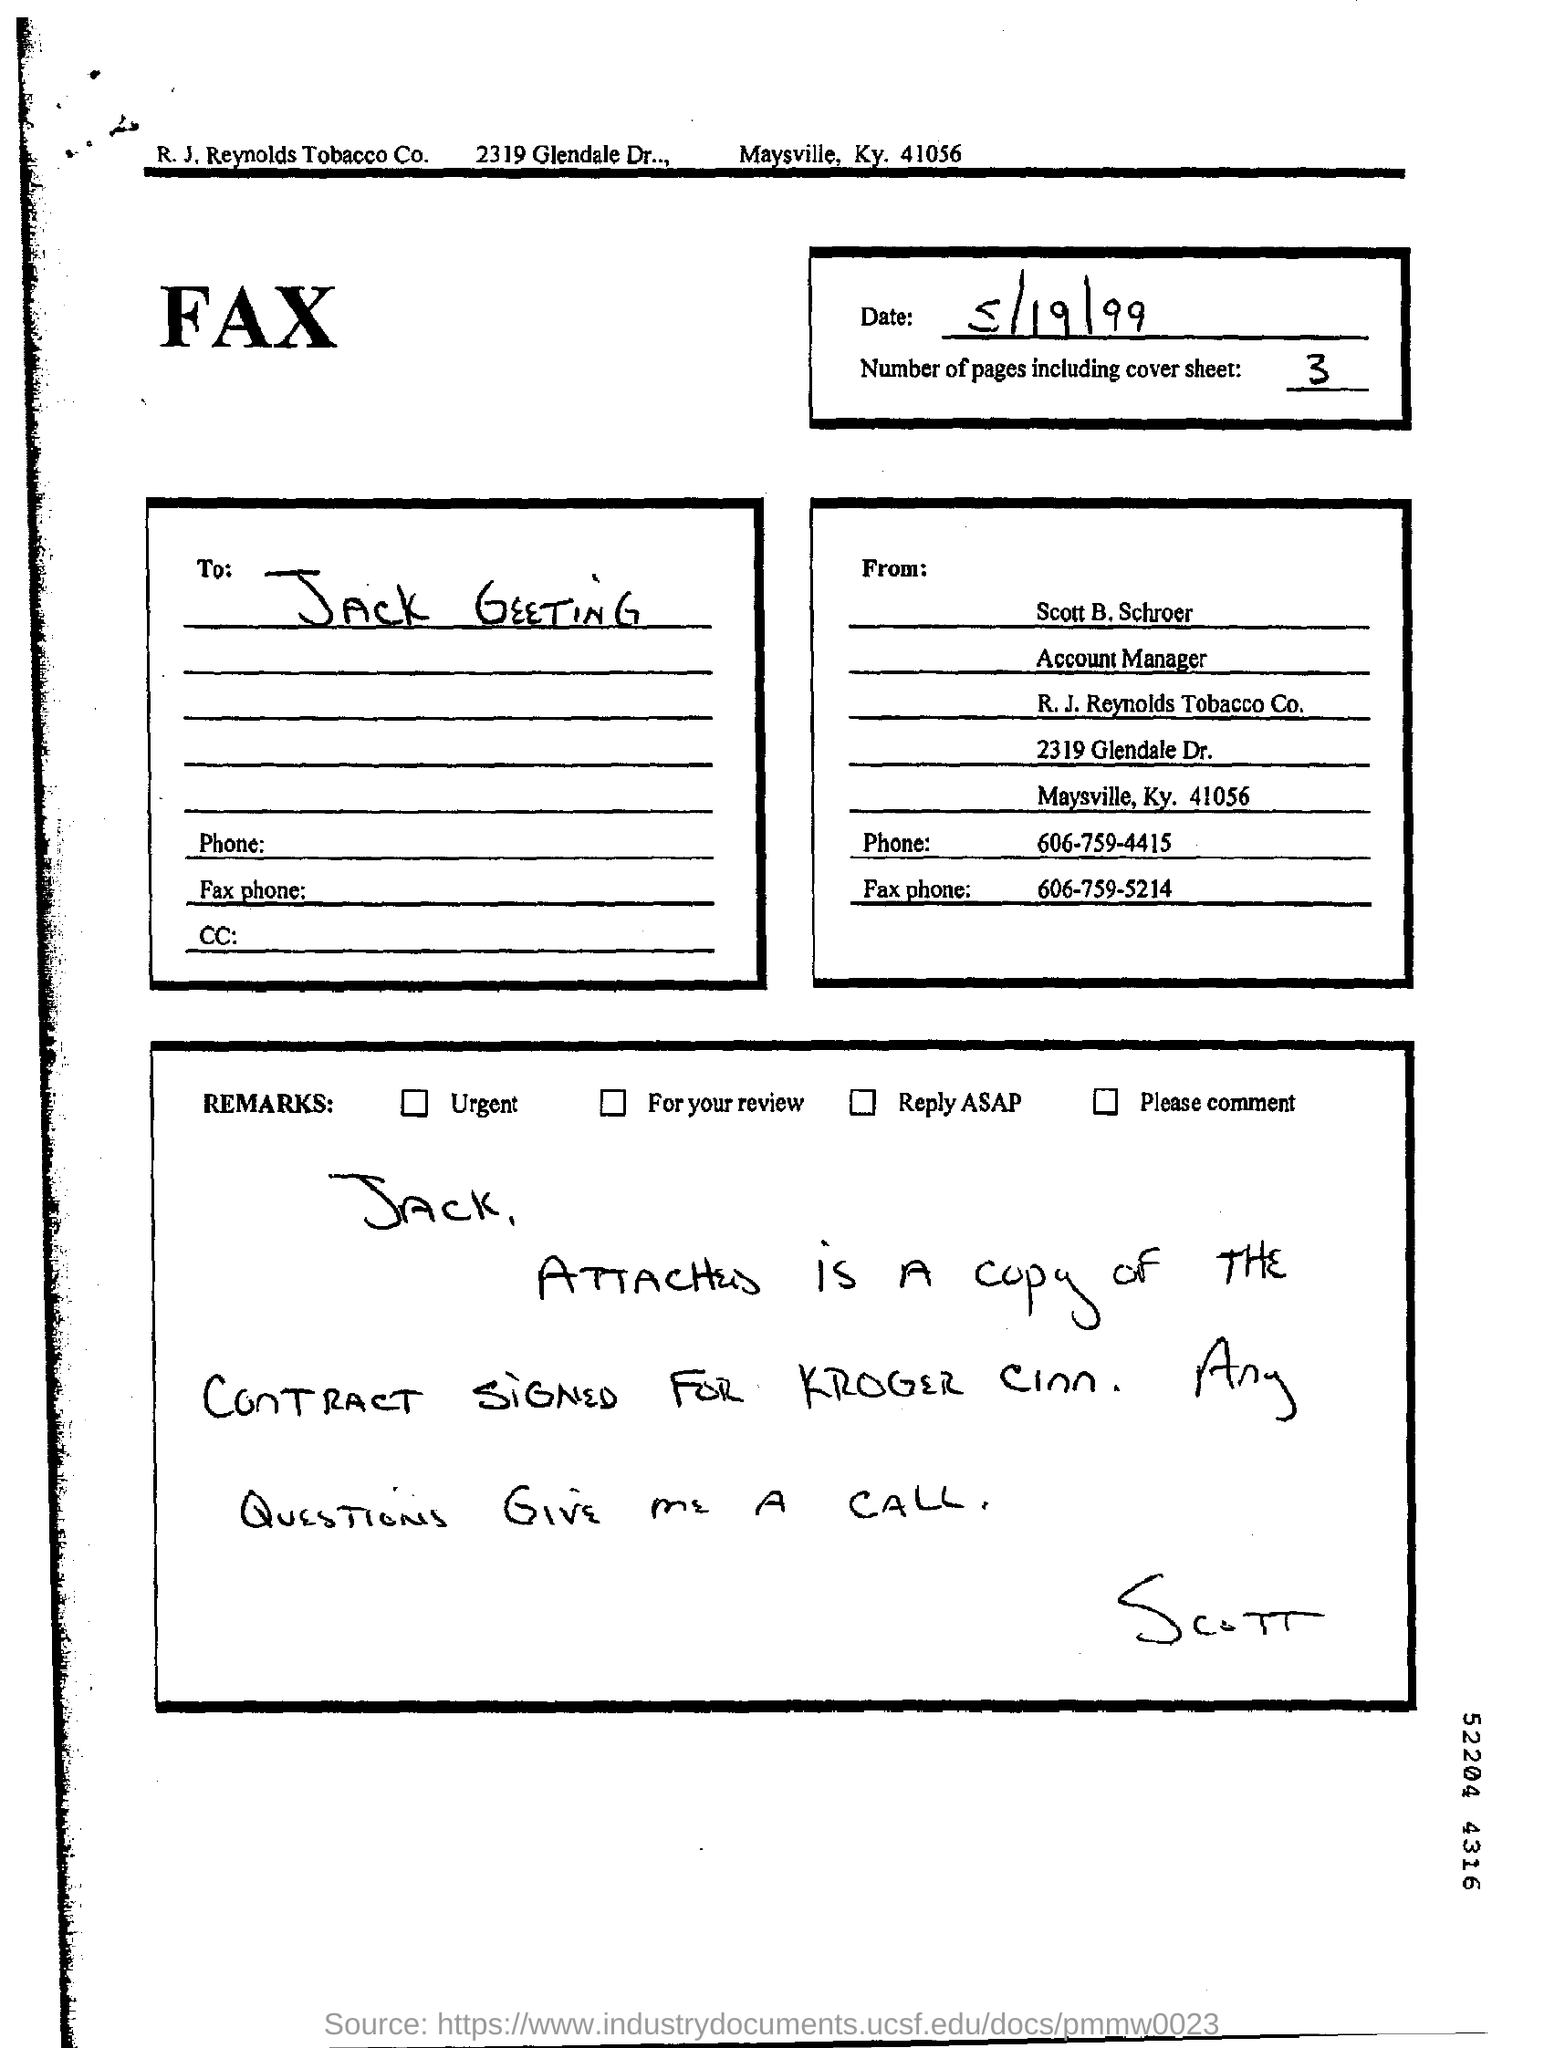To whom, the Fax is being sent?
Ensure brevity in your answer.  JACK GEETING. What is the date mentioned in the FAX sheet?
Your answer should be very brief. 5/19/99. How many pages are there in the fax including cover sheet?
Offer a very short reply. 3. Who is the sender of the FAX?
Ensure brevity in your answer.  Scott B. Schroer. What is the designation of Scott B. Schroer?
Keep it short and to the point. Account Manager. What is the Phone No of Scott B. Schroer?
Your response must be concise. 606-759-4415. What is the Fax Phone No given?
Your response must be concise. 606-759-5214. 